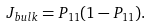Convert formula to latex. <formula><loc_0><loc_0><loc_500><loc_500>J _ { b u l k } = P _ { 1 1 } ( 1 - P _ { 1 1 } ) .</formula> 